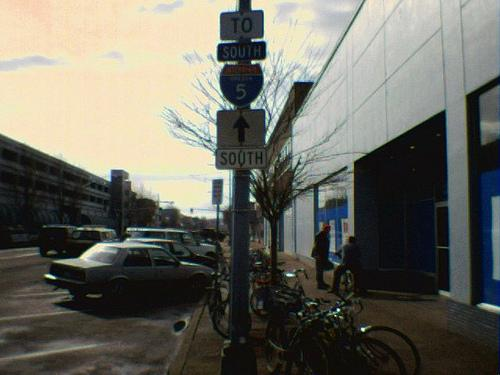Why are the bikes on the poles?

Choices:
A) lost
B) for sale
C) keep safe
D) stolen keep safe 